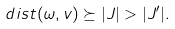Convert formula to latex. <formula><loc_0><loc_0><loc_500><loc_500>d i s t ( \omega , v ) \succeq | J | > | J ^ { \prime } | .</formula> 